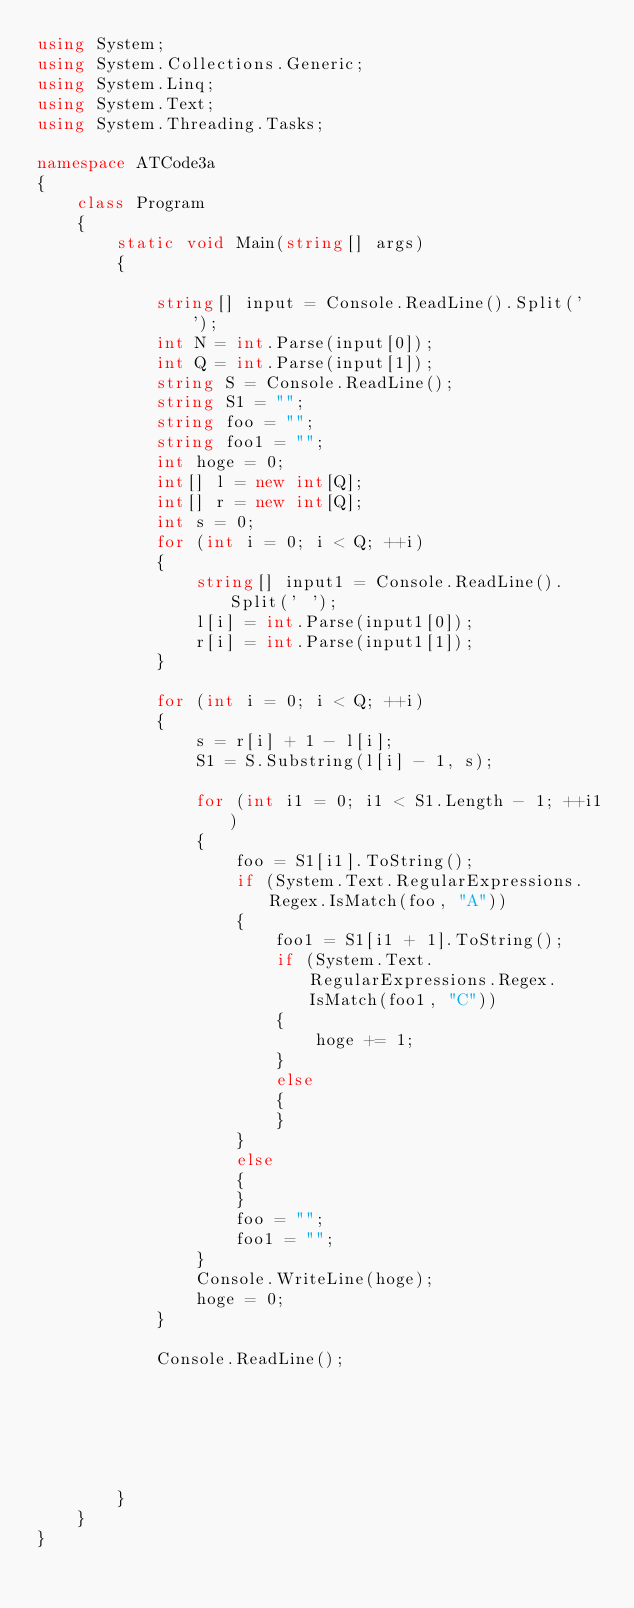<code> <loc_0><loc_0><loc_500><loc_500><_C#_>using System;
using System.Collections.Generic;
using System.Linq;
using System.Text;
using System.Threading.Tasks;

namespace ATCode3a
{
    class Program
    {
        static void Main(string[] args)
        {

            string[] input = Console.ReadLine().Split(' ');
            int N = int.Parse(input[0]);
            int Q = int.Parse(input[1]);
            string S = Console.ReadLine();
            string S1 = "";
            string foo = "";
            string foo1 = "";
            int hoge = 0;
            int[] l = new int[Q];
            int[] r = new int[Q];
            int s = 0;
            for (int i = 0; i < Q; ++i)
            {
                string[] input1 = Console.ReadLine().Split(' ');
                l[i] = int.Parse(input1[0]);
                r[i] = int.Parse(input1[1]);
            }

            for (int i = 0; i < Q; ++i)
            {
                s = r[i] + 1 - l[i];
                S1 = S.Substring(l[i] - 1, s);

                for (int i1 = 0; i1 < S1.Length - 1; ++i1)
                {
                    foo = S1[i1].ToString();
                    if (System.Text.RegularExpressions.Regex.IsMatch(foo, "A"))
                    {
                        foo1 = S1[i1 + 1].ToString();
                        if (System.Text.RegularExpressions.Regex.IsMatch(foo1, "C"))
                        {
                            hoge += 1;
                        }
                        else
                        {
                        }
                    }
                    else
                    {
                    }
                    foo = "";
                    foo1 = "";
                }
                Console.WriteLine(hoge);
                hoge = 0;
            }
           
            Console.ReadLine();






        }
    }
}
</code> 